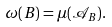<formula> <loc_0><loc_0><loc_500><loc_500>\omega ( B ) = \mu ( \mathcal { A } _ { B } ) .</formula> 